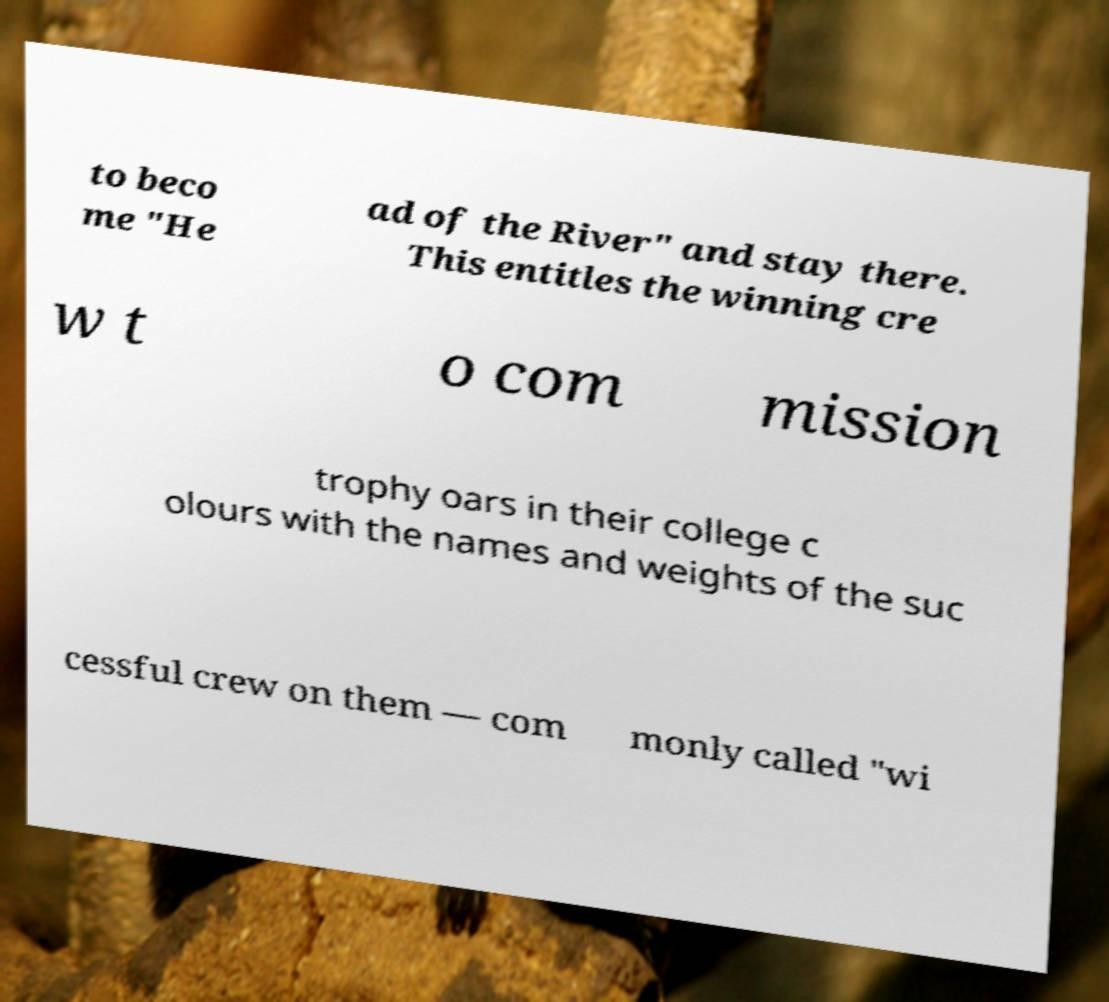What messages or text are displayed in this image? I need them in a readable, typed format. to beco me "He ad of the River" and stay there. This entitles the winning cre w t o com mission trophy oars in their college c olours with the names and weights of the suc cessful crew on them — com monly called "wi 